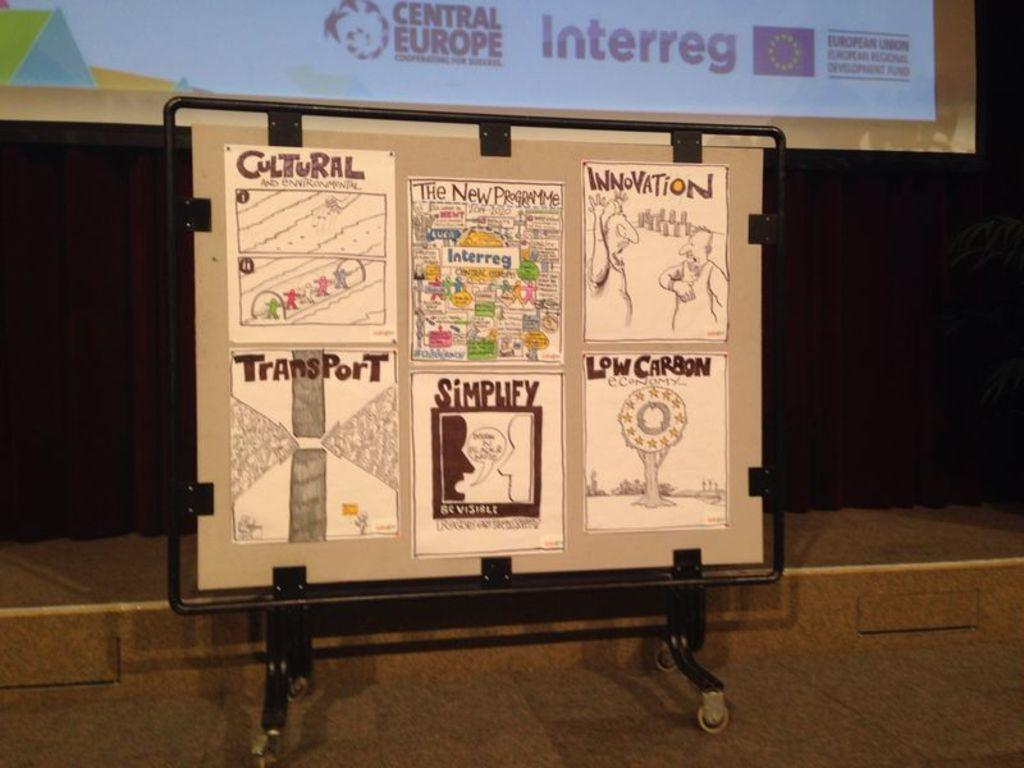What is the main object in the image? There is a board in the image. What is on the board? Papers are pasted on the board. Where is the board located? The board is placed on the floor. Can you see any veins on the board in the image? There are no veins visible on the board in the image. What type of locket is hanging from the board in the image? There is no locket present on the board in the image. 